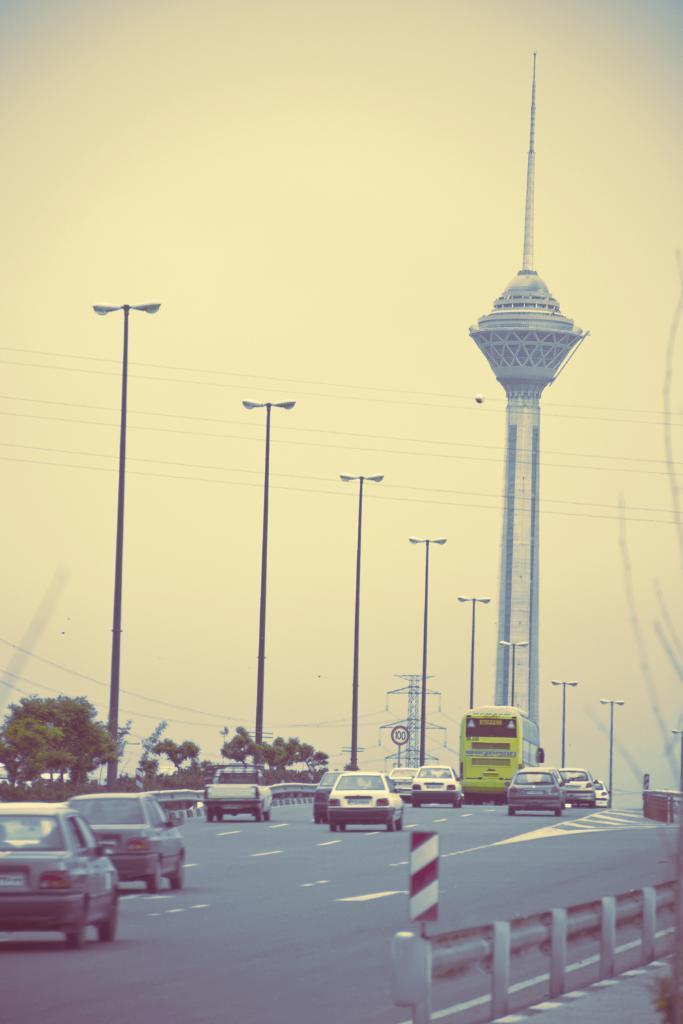Please provide a concise description of this image. There is a road. On the road there are many vehicles. On the right side there is a railing. In the back there are street light poles, trees, tower and sky. Also there is a sign board in the background. 